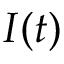<formula> <loc_0><loc_0><loc_500><loc_500>I ( t )</formula> 